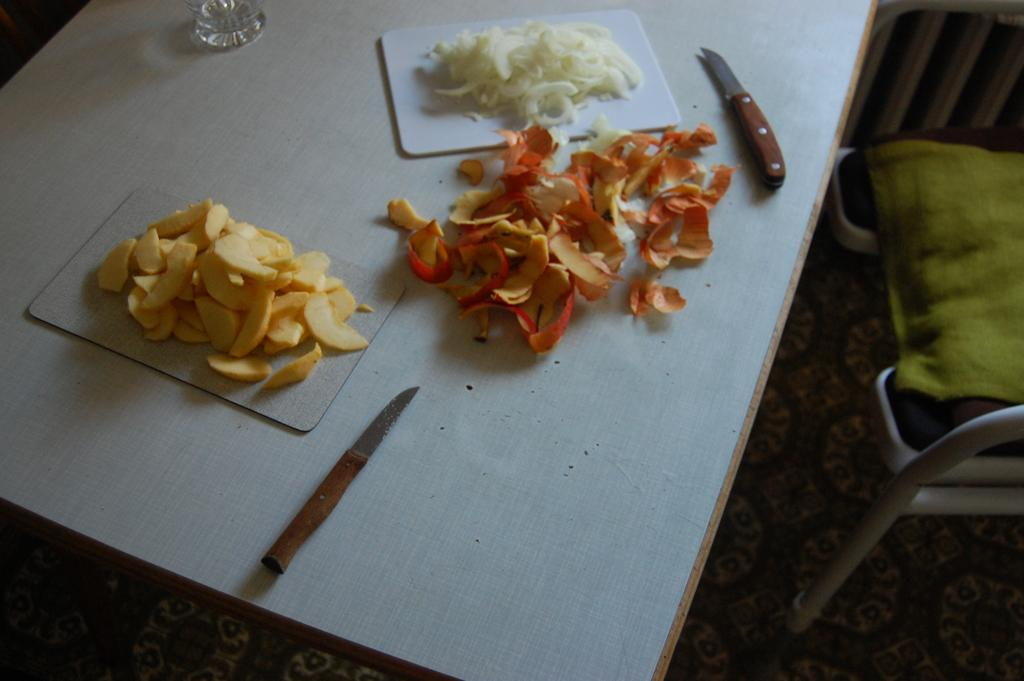What type of furniture is present in the image? The image contains a table. What objects are on the table? There are knives, chopping boards, food, and a glass on the table. What is the purpose of the chopping boards? The chopping boards are likely used for cutting or preparing food. What is covering the chair in the image? There is a cloth on a chair. What color are the eggs on the table in the image? There are no eggs present in the image. What type of metal is used to make the knives on the table? The image does not provide information about the material used to make the knives. 